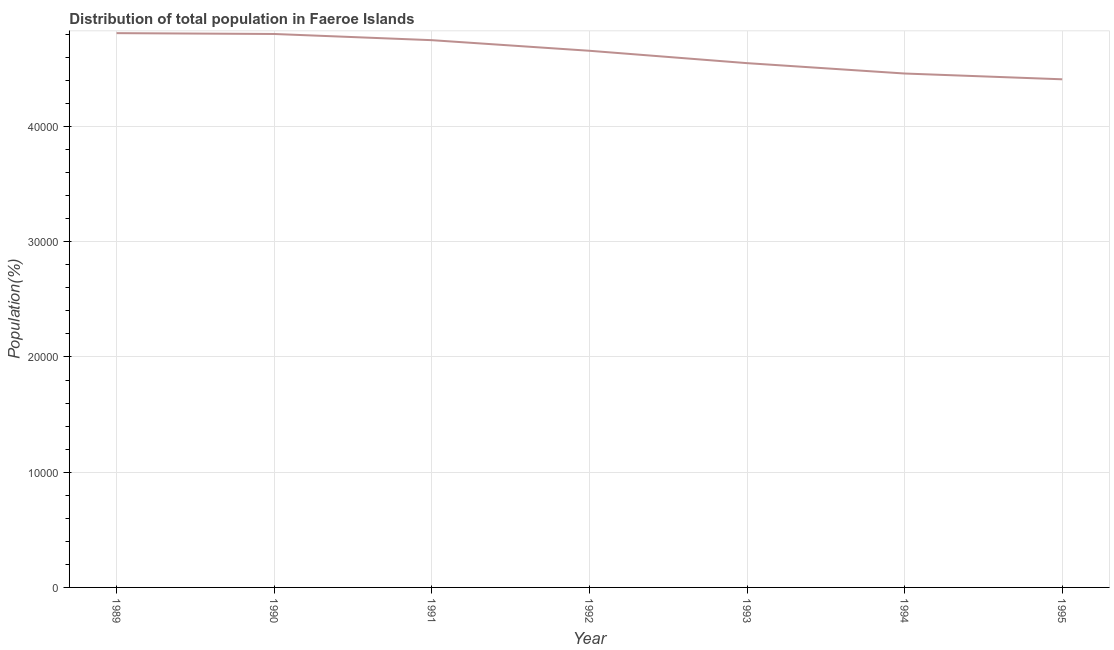What is the population in 1989?
Make the answer very short. 4.81e+04. Across all years, what is the maximum population?
Your response must be concise. 4.81e+04. Across all years, what is the minimum population?
Give a very brief answer. 4.41e+04. In which year was the population maximum?
Offer a terse response. 1989. In which year was the population minimum?
Provide a succinct answer. 1995. What is the sum of the population?
Your answer should be compact. 3.24e+05. What is the difference between the population in 1991 and 1994?
Provide a short and direct response. 2894. What is the average population per year?
Your answer should be very brief. 4.63e+04. What is the median population?
Your answer should be compact. 4.66e+04. In how many years, is the population greater than 18000 %?
Provide a succinct answer. 7. What is the ratio of the population in 1994 to that in 1995?
Offer a very short reply. 1.01. What is the difference between the highest and the second highest population?
Offer a terse response. 74. What is the difference between the highest and the lowest population?
Your response must be concise. 4006. Does the population monotonically increase over the years?
Give a very brief answer. No. What is the difference between two consecutive major ticks on the Y-axis?
Your answer should be very brief. 10000. Are the values on the major ticks of Y-axis written in scientific E-notation?
Give a very brief answer. No. Does the graph contain any zero values?
Offer a terse response. No. Does the graph contain grids?
Ensure brevity in your answer.  Yes. What is the title of the graph?
Give a very brief answer. Distribution of total population in Faeroe Islands . What is the label or title of the Y-axis?
Your answer should be compact. Population(%). What is the Population(%) of 1989?
Your response must be concise. 4.81e+04. What is the Population(%) of 1990?
Provide a short and direct response. 4.80e+04. What is the Population(%) of 1991?
Offer a very short reply. 4.75e+04. What is the Population(%) in 1992?
Provide a short and direct response. 4.66e+04. What is the Population(%) in 1993?
Keep it short and to the point. 4.55e+04. What is the Population(%) in 1994?
Make the answer very short. 4.46e+04. What is the Population(%) of 1995?
Your response must be concise. 4.41e+04. What is the difference between the Population(%) in 1989 and 1991?
Ensure brevity in your answer.  611. What is the difference between the Population(%) in 1989 and 1992?
Offer a terse response. 1531. What is the difference between the Population(%) in 1989 and 1993?
Your answer should be very brief. 2604. What is the difference between the Population(%) in 1989 and 1994?
Your response must be concise. 3505. What is the difference between the Population(%) in 1989 and 1995?
Your answer should be compact. 4006. What is the difference between the Population(%) in 1990 and 1991?
Make the answer very short. 537. What is the difference between the Population(%) in 1990 and 1992?
Give a very brief answer. 1457. What is the difference between the Population(%) in 1990 and 1993?
Ensure brevity in your answer.  2530. What is the difference between the Population(%) in 1990 and 1994?
Provide a short and direct response. 3431. What is the difference between the Population(%) in 1990 and 1995?
Provide a short and direct response. 3932. What is the difference between the Population(%) in 1991 and 1992?
Ensure brevity in your answer.  920. What is the difference between the Population(%) in 1991 and 1993?
Your response must be concise. 1993. What is the difference between the Population(%) in 1991 and 1994?
Offer a terse response. 2894. What is the difference between the Population(%) in 1991 and 1995?
Provide a succinct answer. 3395. What is the difference between the Population(%) in 1992 and 1993?
Keep it short and to the point. 1073. What is the difference between the Population(%) in 1992 and 1994?
Provide a succinct answer. 1974. What is the difference between the Population(%) in 1992 and 1995?
Offer a terse response. 2475. What is the difference between the Population(%) in 1993 and 1994?
Give a very brief answer. 901. What is the difference between the Population(%) in 1993 and 1995?
Offer a very short reply. 1402. What is the difference between the Population(%) in 1994 and 1995?
Give a very brief answer. 501. What is the ratio of the Population(%) in 1989 to that in 1992?
Your response must be concise. 1.03. What is the ratio of the Population(%) in 1989 to that in 1993?
Offer a very short reply. 1.06. What is the ratio of the Population(%) in 1989 to that in 1994?
Your answer should be very brief. 1.08. What is the ratio of the Population(%) in 1989 to that in 1995?
Ensure brevity in your answer.  1.09. What is the ratio of the Population(%) in 1990 to that in 1991?
Give a very brief answer. 1.01. What is the ratio of the Population(%) in 1990 to that in 1992?
Your response must be concise. 1.03. What is the ratio of the Population(%) in 1990 to that in 1993?
Ensure brevity in your answer.  1.06. What is the ratio of the Population(%) in 1990 to that in 1994?
Your response must be concise. 1.08. What is the ratio of the Population(%) in 1990 to that in 1995?
Provide a succinct answer. 1.09. What is the ratio of the Population(%) in 1991 to that in 1992?
Give a very brief answer. 1.02. What is the ratio of the Population(%) in 1991 to that in 1993?
Keep it short and to the point. 1.04. What is the ratio of the Population(%) in 1991 to that in 1994?
Provide a short and direct response. 1.06. What is the ratio of the Population(%) in 1991 to that in 1995?
Your answer should be very brief. 1.08. What is the ratio of the Population(%) in 1992 to that in 1994?
Your response must be concise. 1.04. What is the ratio of the Population(%) in 1992 to that in 1995?
Offer a very short reply. 1.06. What is the ratio of the Population(%) in 1993 to that in 1994?
Offer a terse response. 1.02. What is the ratio of the Population(%) in 1993 to that in 1995?
Ensure brevity in your answer.  1.03. What is the ratio of the Population(%) in 1994 to that in 1995?
Offer a very short reply. 1.01. 